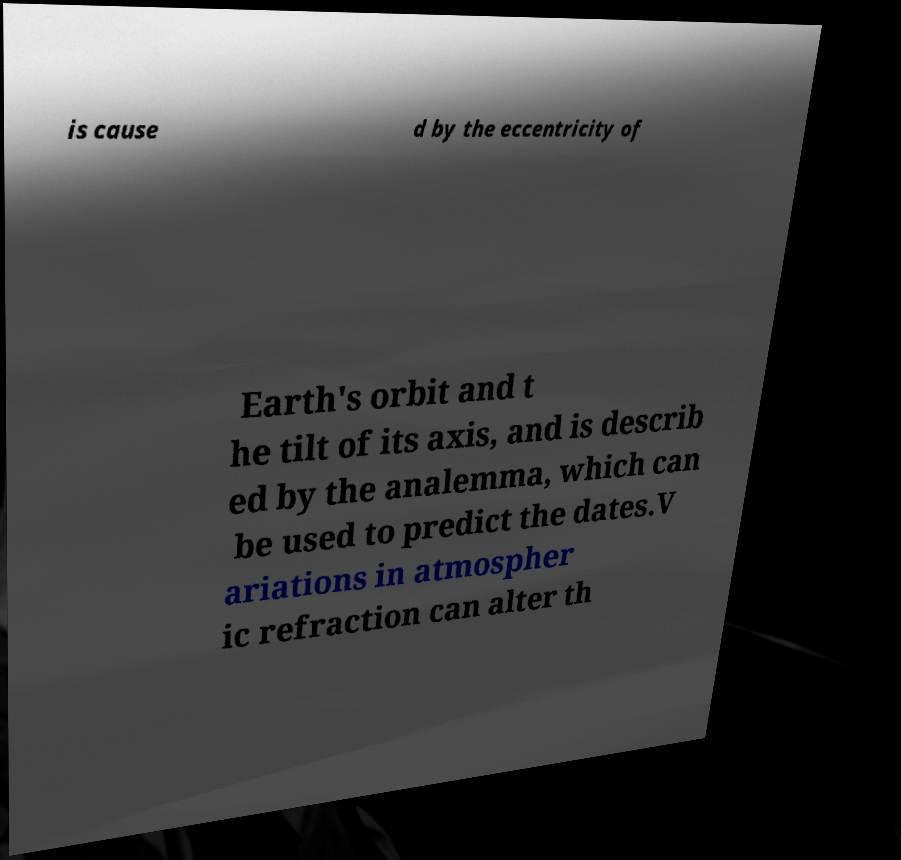Could you extract and type out the text from this image? is cause d by the eccentricity of Earth's orbit and t he tilt of its axis, and is describ ed by the analemma, which can be used to predict the dates.V ariations in atmospher ic refraction can alter th 